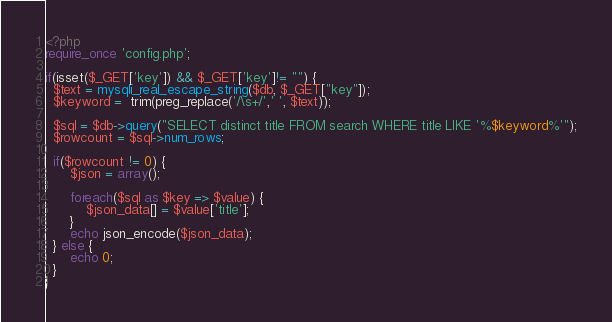<code> <loc_0><loc_0><loc_500><loc_500><_PHP_><?php
require_once 'config.php';

if(isset($_GET['key']) && $_GET['key']!= "") {
  $text = mysqli_real_escape_string($db, $_GET["key"]);
  $keyword =  trim(preg_replace('/\s+/',' ', $text));
  
  $sql = $db->query("SELECT distinct title FROM search WHERE title LIKE '%$keyword%'");
  $rowcount = $sql->num_rows;
  
  if($rowcount != 0) {
	  $json = array();
	  
	  foreach($sql as $key => $value) {
		  $json_data[] = $value['title'];
	  }
	  echo json_encode($json_data);
  } else {
	  echo 0;
  }
}

</code> 